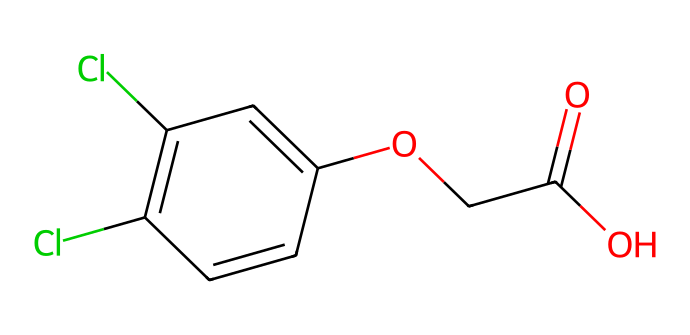What is the molecular formula of 2,4-D? To determine the molecular formula, we count the number of each type of atom in the structure represented by the SMILES notation. The molecule consists of 8 carbon atoms, 6 hydrogen atoms, 2 chlorine atoms, and 4 oxygen atoms. Therefore, the molecular formula is C8H6Cl2O4.
Answer: C8H6Cl2O4 How many chlorine (Cl) atoms are present in 2,4-D? By inspecting the chemical structure or the SMILES representation, we can clearly identify two chlorine atoms represented by "Cl" in the formula.
Answer: 2 What is the functional group present in 2,4-D? The functional group here is a carboxylic acid (as indicated by the -COOH group which contains one carbon atom, two oxygen atoms, and a hydrogen atom). This is evident from the part of the SMILES notation "C(=O)O".
Answer: carboxylic acid What type of herbicide is 2,4-D? 2,4-D is known as a synthetic auxin herbicide, which means it mimics natural plant hormones (auxins) that regulate growth. This classification is informed by its chemical structure, which influences its herbicidal properties.
Answer: synthetic auxin What is the main use of 2,4-D? The primary use of 2,4-D is as a selective herbicide for controlling broadleaf weeds in various crops and lawns. This is based on its mechanism of action as a growth regulator affecting target plants without harming grasses.
Answer: weed control What is the total number of oxygen (O) atoms in 2,4-D? Upon examining the molecule, there are a total of four oxygen atoms present, derived from the carboxylic acid group and the ether linkage. Counting gives us the total.
Answer: 4 How does 2,4-D affect plant growth? 2,4-D disrupts normal growth patterns by overstimulating plant cell growth, leading to uncontrolled growth and eventual death of susceptible plants. This is due to its function as a synthetic auxin affecting growth regulation.
Answer: growth disruption 